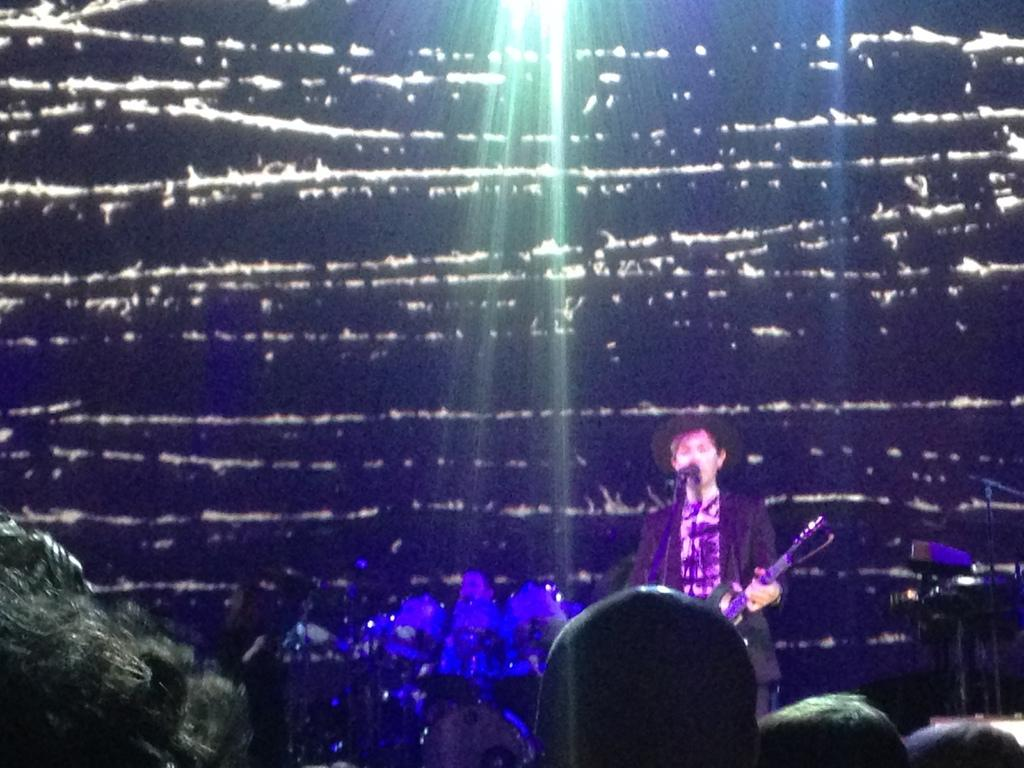What is the person in the foreground holding in the image? The person is standing and holding a guitar. What equipment is present for amplifying sound? There is a microphone with a stand in the image. Can you describe the person in the background? There is a person in the background, but no specific details are provided. What type of musical instrument can be seen in the background? There is a musical instrument in the background, but no specific details are provided. Who might be listening to the performance in the image? There are people in the audience who might be listening to the performance. What type of trouble is the person with the fang experiencing in the image? There is no person with a fang or any indication of trouble in the image. 